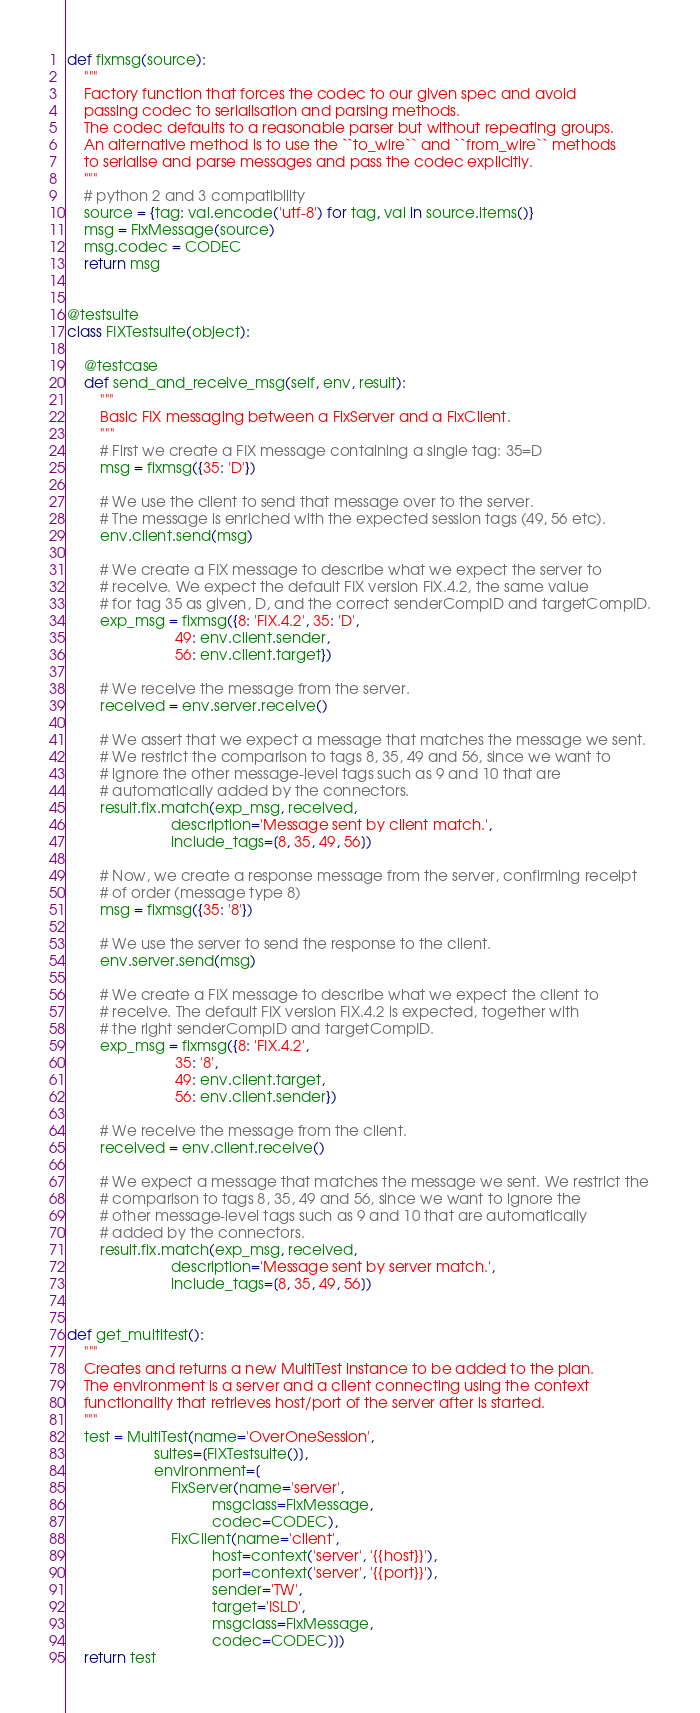<code> <loc_0><loc_0><loc_500><loc_500><_Python_>def fixmsg(source):
    """
    Factory function that forces the codec to our given spec and avoid
    passing codec to serialisation and parsing methods.
    The codec defaults to a reasonable parser but without repeating groups.
    An alternative method is to use the ``to_wire`` and ``from_wire`` methods
    to serialise and parse messages and pass the codec explicitly.
    """
    # python 2 and 3 compatibility
    source = {tag: val.encode('utf-8') for tag, val in source.items()}
    msg = FixMessage(source)
    msg.codec = CODEC
    return msg


@testsuite
class FIXTestsuite(object):

    @testcase
    def send_and_receive_msg(self, env, result):
        """
        Basic FIX messaging between a FixServer and a FixClient.
        """
        # First we create a FIX message containing a single tag: 35=D
        msg = fixmsg({35: 'D'})

        # We use the client to send that message over to the server.
        # The message is enriched with the expected session tags (49, 56 etc).
        env.client.send(msg)

        # We create a FIX message to describe what we expect the server to
        # receive. We expect the default FIX version FIX.4.2, the same value
        # for tag 35 as given, D, and the correct senderCompID and targetCompID.
        exp_msg = fixmsg({8: 'FIX.4.2', 35: 'D',
                          49: env.client.sender,
                          56: env.client.target})

        # We receive the message from the server.
        received = env.server.receive()

        # We assert that we expect a message that matches the message we sent.
        # We restrict the comparison to tags 8, 35, 49 and 56, since we want to
        # ignore the other message-level tags such as 9 and 10 that are
        # automatically added by the connectors.
        result.fix.match(exp_msg, received,
                         description='Message sent by client match.',
                         include_tags=[8, 35, 49, 56])

        # Now, we create a response message from the server, confirming receipt
        # of order (message type 8)
        msg = fixmsg({35: '8'})

        # We use the server to send the response to the client.
        env.server.send(msg)

        # We create a FIX message to describe what we expect the client to
        # receive. The default FIX version FIX.4.2 is expected, together with
        # the right senderCompID and targetCompID.
        exp_msg = fixmsg({8: 'FIX.4.2',
                          35: '8',
                          49: env.client.target,
                          56: env.client.sender})

        # We receive the message from the client.
        received = env.client.receive()

        # We expect a message that matches the message we sent. We restrict the
        # comparison to tags 8, 35, 49 and 56, since we want to ignore the
        # other message-level tags such as 9 and 10 that are automatically
        # added by the connectors.
        result.fix.match(exp_msg, received,
                         description='Message sent by server match.',
                         include_tags=[8, 35, 49, 56])


def get_multitest():
    """
    Creates and returns a new MultiTest instance to be added to the plan.
    The environment is a server and a client connecting using the context
    functionality that retrieves host/port of the server after is started.
    """
    test = MultiTest(name='OverOneSession',
                     suites=[FIXTestsuite()],
                     environment=[
                         FixServer(name='server',
                                   msgclass=FixMessage,
                                   codec=CODEC),
                         FixClient(name='client',
                                   host=context('server', '{{host}}'),
                                   port=context('server', '{{port}}'),
                                   sender='TW',
                                   target='ISLD',
                                   msgclass=FixMessage,
                                   codec=CODEC)])
    return test
</code> 